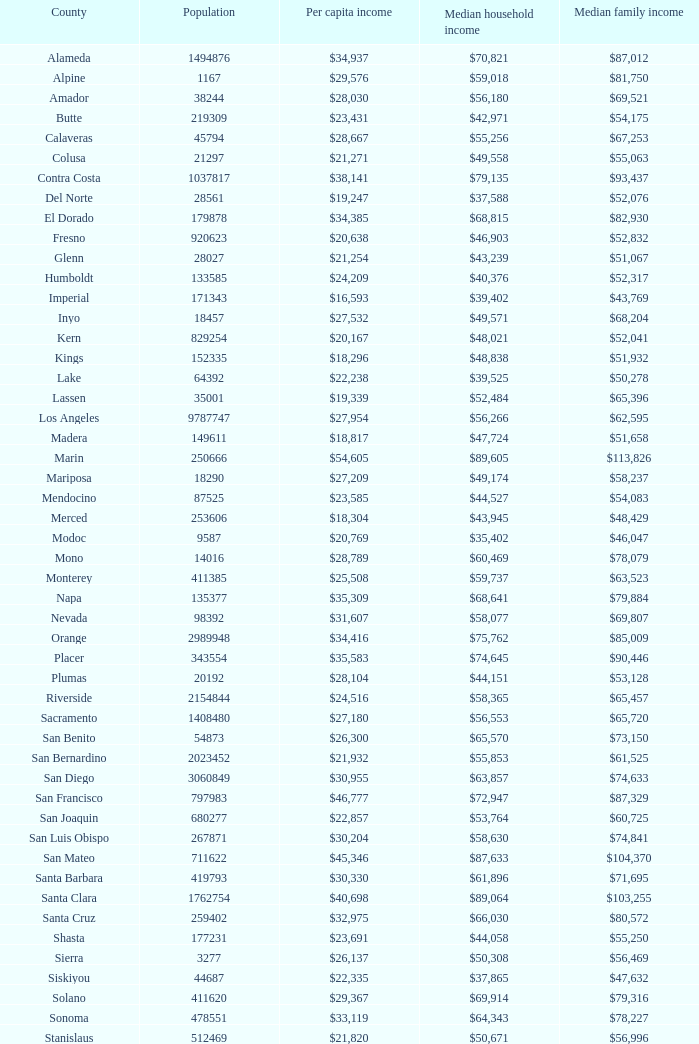In butte, what is the typical income for a household? $42,971. 